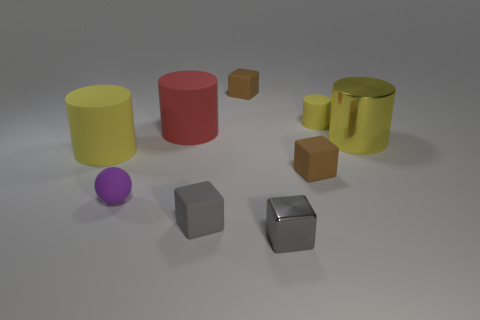There is another rubber cylinder that is the same color as the tiny rubber cylinder; what is its size?
Provide a short and direct response. Large. Is the color of the small cylinder the same as the metallic cylinder?
Offer a terse response. Yes. Is the number of small balls that are in front of the gray metallic thing the same as the number of big rubber cylinders that are to the right of the tiny ball?
Your answer should be very brief. No. Is there a matte block that has the same size as the yellow shiny object?
Offer a very short reply. No. The red thing has what size?
Offer a very short reply. Large. Is the number of large things right of the yellow metallic object the same as the number of big purple metallic cylinders?
Offer a very short reply. Yes. What number of other things are the same color as the tiny metallic object?
Offer a terse response. 1. The tiny rubber thing that is both to the right of the tiny gray shiny cube and to the left of the small yellow matte thing is what color?
Offer a terse response. Brown. There is a matte block that is left of the tiny block behind the yellow cylinder left of the ball; what size is it?
Keep it short and to the point. Small. How many things are either big red matte cylinders behind the yellow metal object or big yellow things that are on the right side of the small gray metallic block?
Your answer should be compact. 2. 